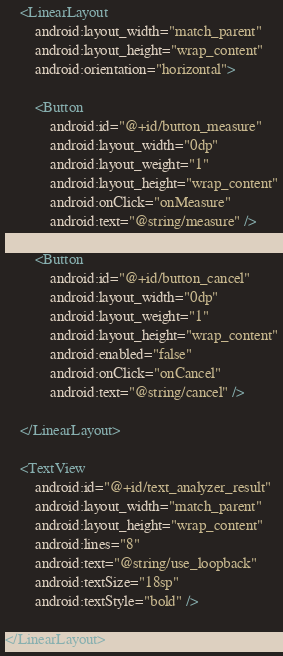Convert code to text. <code><loc_0><loc_0><loc_500><loc_500><_XML_>    <LinearLayout
        android:layout_width="match_parent"
        android:layout_height="wrap_content"
        android:orientation="horizontal">

        <Button
            android:id="@+id/button_measure"
            android:layout_width="0dp"
            android:layout_weight="1"
            android:layout_height="wrap_content"
            android:onClick="onMeasure"
            android:text="@string/measure" />

        <Button
            android:id="@+id/button_cancel"
            android:layout_width="0dp"
            android:layout_weight="1"
            android:layout_height="wrap_content"
            android:enabled="false"
            android:onClick="onCancel"
            android:text="@string/cancel" />

    </LinearLayout>

    <TextView
        android:id="@+id/text_analyzer_result"
        android:layout_width="match_parent"
        android:layout_height="wrap_content"
        android:lines="8"
        android:text="@string/use_loopback"
        android:textSize="18sp"
        android:textStyle="bold" />

</LinearLayout>
</code> 